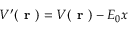Convert formula to latex. <formula><loc_0><loc_0><loc_500><loc_500>V ^ { \prime } ( r ) = V ( r ) - E _ { 0 } x</formula> 